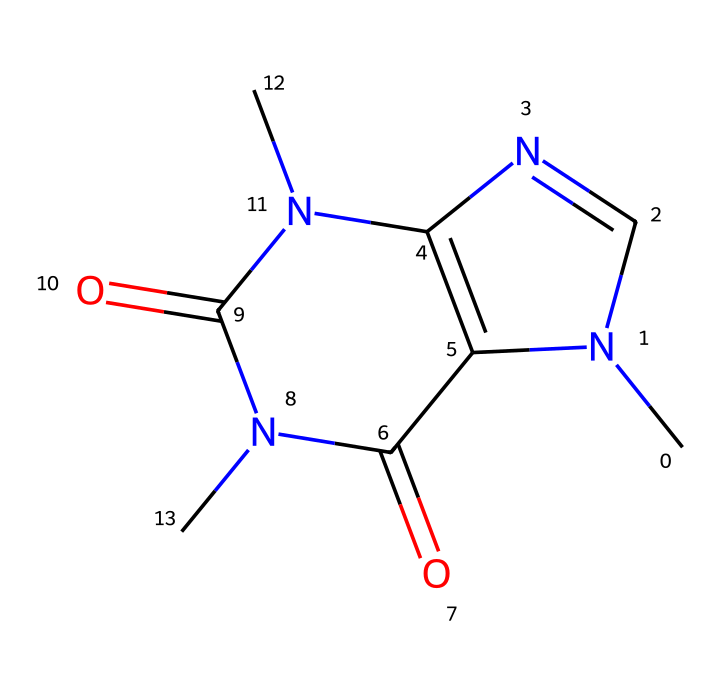How many nitrogen atoms are present in caffeine? The SMILES representation includes two 'N' characters, which correspond to the nitrogen atoms in the chemical structure. Counting these gives a total of two nitrogen atoms.
Answer: 2 What is the molecular formula of caffeine? To determine the molecular formula from the SMILES representation, we need to count the number of each type of atom: 8 carbon (C), 10 hydrogen (H), 4 nitrogen (N), and 2 oxygen (O) atoms, resulting in the formula C8H10N4O2.
Answer: C8H10N4O2 How many rings are present in the structure of caffeine? The presence of two distinct ring systems can be identified by examining the connected structure within the SMILES; thus, caffeine contains two rings.
Answer: 2 What is the primary relation of caffeine to the human body? Caffeine functions primarily as a central nervous system stimulant, promoting alertness and reducing fatigue, illustrated by its interaction within the body after consumption.
Answer: stimulant What type of medicinal compound does caffeine represent? Caffeine is classified as an alkaloid due to its nitrogen-containing structure and physiological effects; its classification arises from specific structural characteristics of alkaloids.
Answer: alkaloid What is the significance of the "N" atoms in the chemical structure? The nitrogen atoms in caffeine's structure contribute to its pharmacological properties, particularly influencing its stimulant effects due to their role in forming bonds within the molecular framework.
Answer: pharmacological effects 